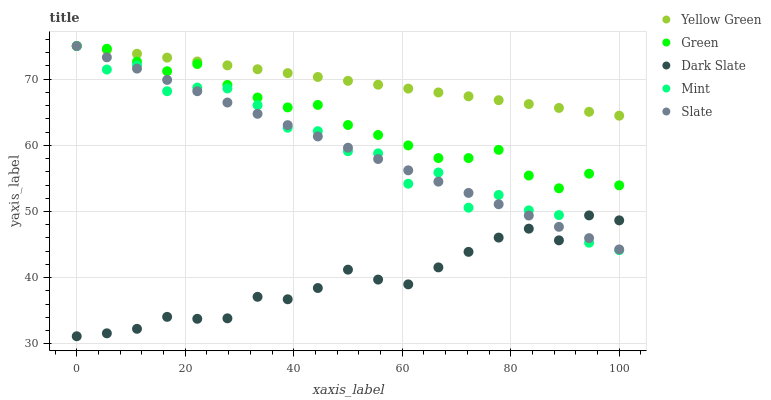Does Dark Slate have the minimum area under the curve?
Answer yes or no. Yes. Does Yellow Green have the maximum area under the curve?
Answer yes or no. Yes. Does Slate have the minimum area under the curve?
Answer yes or no. No. Does Slate have the maximum area under the curve?
Answer yes or no. No. Is Slate the smoothest?
Answer yes or no. Yes. Is Mint the roughest?
Answer yes or no. Yes. Is Mint the smoothest?
Answer yes or no. No. Is Slate the roughest?
Answer yes or no. No. Does Dark Slate have the lowest value?
Answer yes or no. Yes. Does Slate have the lowest value?
Answer yes or no. No. Does Yellow Green have the highest value?
Answer yes or no. Yes. Is Dark Slate less than Green?
Answer yes or no. Yes. Is Yellow Green greater than Dark Slate?
Answer yes or no. Yes. Does Mint intersect Dark Slate?
Answer yes or no. Yes. Is Mint less than Dark Slate?
Answer yes or no. No. Is Mint greater than Dark Slate?
Answer yes or no. No. Does Dark Slate intersect Green?
Answer yes or no. No. 